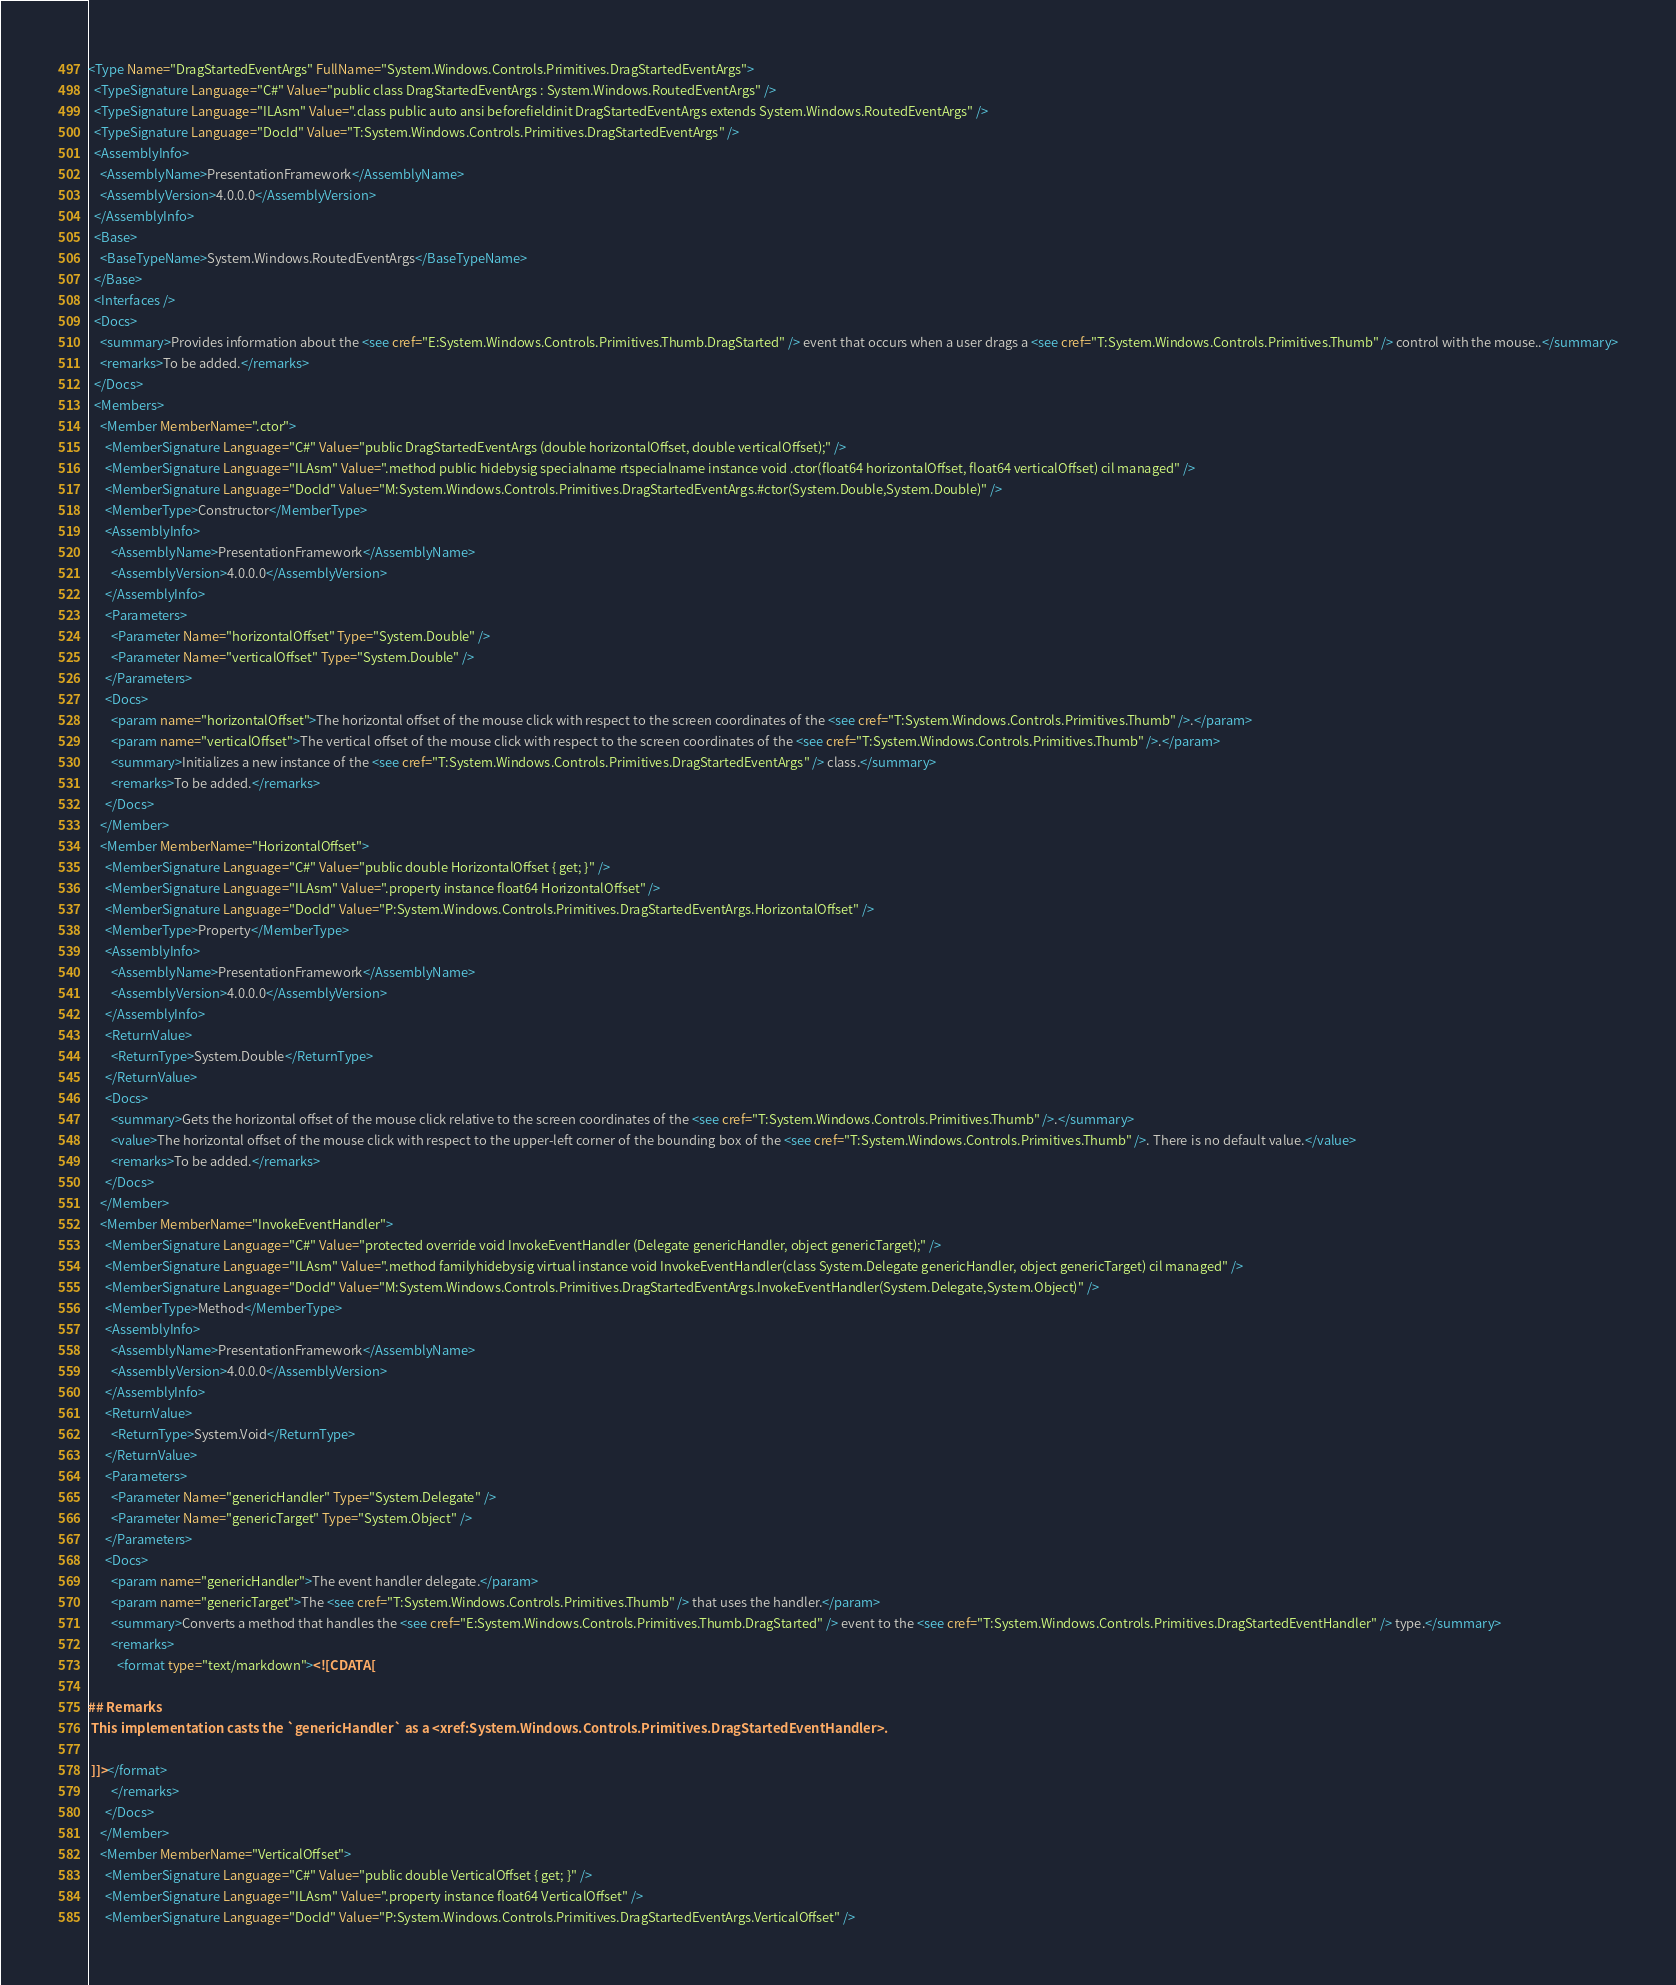<code> <loc_0><loc_0><loc_500><loc_500><_XML_><Type Name="DragStartedEventArgs" FullName="System.Windows.Controls.Primitives.DragStartedEventArgs">
  <TypeSignature Language="C#" Value="public class DragStartedEventArgs : System.Windows.RoutedEventArgs" />
  <TypeSignature Language="ILAsm" Value=".class public auto ansi beforefieldinit DragStartedEventArgs extends System.Windows.RoutedEventArgs" />
  <TypeSignature Language="DocId" Value="T:System.Windows.Controls.Primitives.DragStartedEventArgs" />
  <AssemblyInfo>
    <AssemblyName>PresentationFramework</AssemblyName>
    <AssemblyVersion>4.0.0.0</AssemblyVersion>
  </AssemblyInfo>
  <Base>
    <BaseTypeName>System.Windows.RoutedEventArgs</BaseTypeName>
  </Base>
  <Interfaces />
  <Docs>
    <summary>Provides information about the <see cref="E:System.Windows.Controls.Primitives.Thumb.DragStarted" /> event that occurs when a user drags a <see cref="T:System.Windows.Controls.Primitives.Thumb" /> control with the mouse..</summary>
    <remarks>To be added.</remarks>
  </Docs>
  <Members>
    <Member MemberName=".ctor">
      <MemberSignature Language="C#" Value="public DragStartedEventArgs (double horizontalOffset, double verticalOffset);" />
      <MemberSignature Language="ILAsm" Value=".method public hidebysig specialname rtspecialname instance void .ctor(float64 horizontalOffset, float64 verticalOffset) cil managed" />
      <MemberSignature Language="DocId" Value="M:System.Windows.Controls.Primitives.DragStartedEventArgs.#ctor(System.Double,System.Double)" />
      <MemberType>Constructor</MemberType>
      <AssemblyInfo>
        <AssemblyName>PresentationFramework</AssemblyName>
        <AssemblyVersion>4.0.0.0</AssemblyVersion>
      </AssemblyInfo>
      <Parameters>
        <Parameter Name="horizontalOffset" Type="System.Double" />
        <Parameter Name="verticalOffset" Type="System.Double" />
      </Parameters>
      <Docs>
        <param name="horizontalOffset">The horizontal offset of the mouse click with respect to the screen coordinates of the <see cref="T:System.Windows.Controls.Primitives.Thumb" />.</param>
        <param name="verticalOffset">The vertical offset of the mouse click with respect to the screen coordinates of the <see cref="T:System.Windows.Controls.Primitives.Thumb" />.</param>
        <summary>Initializes a new instance of the <see cref="T:System.Windows.Controls.Primitives.DragStartedEventArgs" /> class.</summary>
        <remarks>To be added.</remarks>
      </Docs>
    </Member>
    <Member MemberName="HorizontalOffset">
      <MemberSignature Language="C#" Value="public double HorizontalOffset { get; }" />
      <MemberSignature Language="ILAsm" Value=".property instance float64 HorizontalOffset" />
      <MemberSignature Language="DocId" Value="P:System.Windows.Controls.Primitives.DragStartedEventArgs.HorizontalOffset" />
      <MemberType>Property</MemberType>
      <AssemblyInfo>
        <AssemblyName>PresentationFramework</AssemblyName>
        <AssemblyVersion>4.0.0.0</AssemblyVersion>
      </AssemblyInfo>
      <ReturnValue>
        <ReturnType>System.Double</ReturnType>
      </ReturnValue>
      <Docs>
        <summary>Gets the horizontal offset of the mouse click relative to the screen coordinates of the <see cref="T:System.Windows.Controls.Primitives.Thumb" />.</summary>
        <value>The horizontal offset of the mouse click with respect to the upper-left corner of the bounding box of the <see cref="T:System.Windows.Controls.Primitives.Thumb" />. There is no default value.</value>
        <remarks>To be added.</remarks>
      </Docs>
    </Member>
    <Member MemberName="InvokeEventHandler">
      <MemberSignature Language="C#" Value="protected override void InvokeEventHandler (Delegate genericHandler, object genericTarget);" />
      <MemberSignature Language="ILAsm" Value=".method familyhidebysig virtual instance void InvokeEventHandler(class System.Delegate genericHandler, object genericTarget) cil managed" />
      <MemberSignature Language="DocId" Value="M:System.Windows.Controls.Primitives.DragStartedEventArgs.InvokeEventHandler(System.Delegate,System.Object)" />
      <MemberType>Method</MemberType>
      <AssemblyInfo>
        <AssemblyName>PresentationFramework</AssemblyName>
        <AssemblyVersion>4.0.0.0</AssemblyVersion>
      </AssemblyInfo>
      <ReturnValue>
        <ReturnType>System.Void</ReturnType>
      </ReturnValue>
      <Parameters>
        <Parameter Name="genericHandler" Type="System.Delegate" />
        <Parameter Name="genericTarget" Type="System.Object" />
      </Parameters>
      <Docs>
        <param name="genericHandler">The event handler delegate.</param>
        <param name="genericTarget">The <see cref="T:System.Windows.Controls.Primitives.Thumb" /> that uses the handler.</param>
        <summary>Converts a method that handles the <see cref="E:System.Windows.Controls.Primitives.Thumb.DragStarted" /> event to the <see cref="T:System.Windows.Controls.Primitives.DragStartedEventHandler" /> type.</summary>
        <remarks>
          <format type="text/markdown"><![CDATA[  
  
## Remarks  
 This implementation casts the `genericHandler` as a <xref:System.Windows.Controls.Primitives.DragStartedEventHandler>.  
  
 ]]></format>
        </remarks>
      </Docs>
    </Member>
    <Member MemberName="VerticalOffset">
      <MemberSignature Language="C#" Value="public double VerticalOffset { get; }" />
      <MemberSignature Language="ILAsm" Value=".property instance float64 VerticalOffset" />
      <MemberSignature Language="DocId" Value="P:System.Windows.Controls.Primitives.DragStartedEventArgs.VerticalOffset" /></code> 